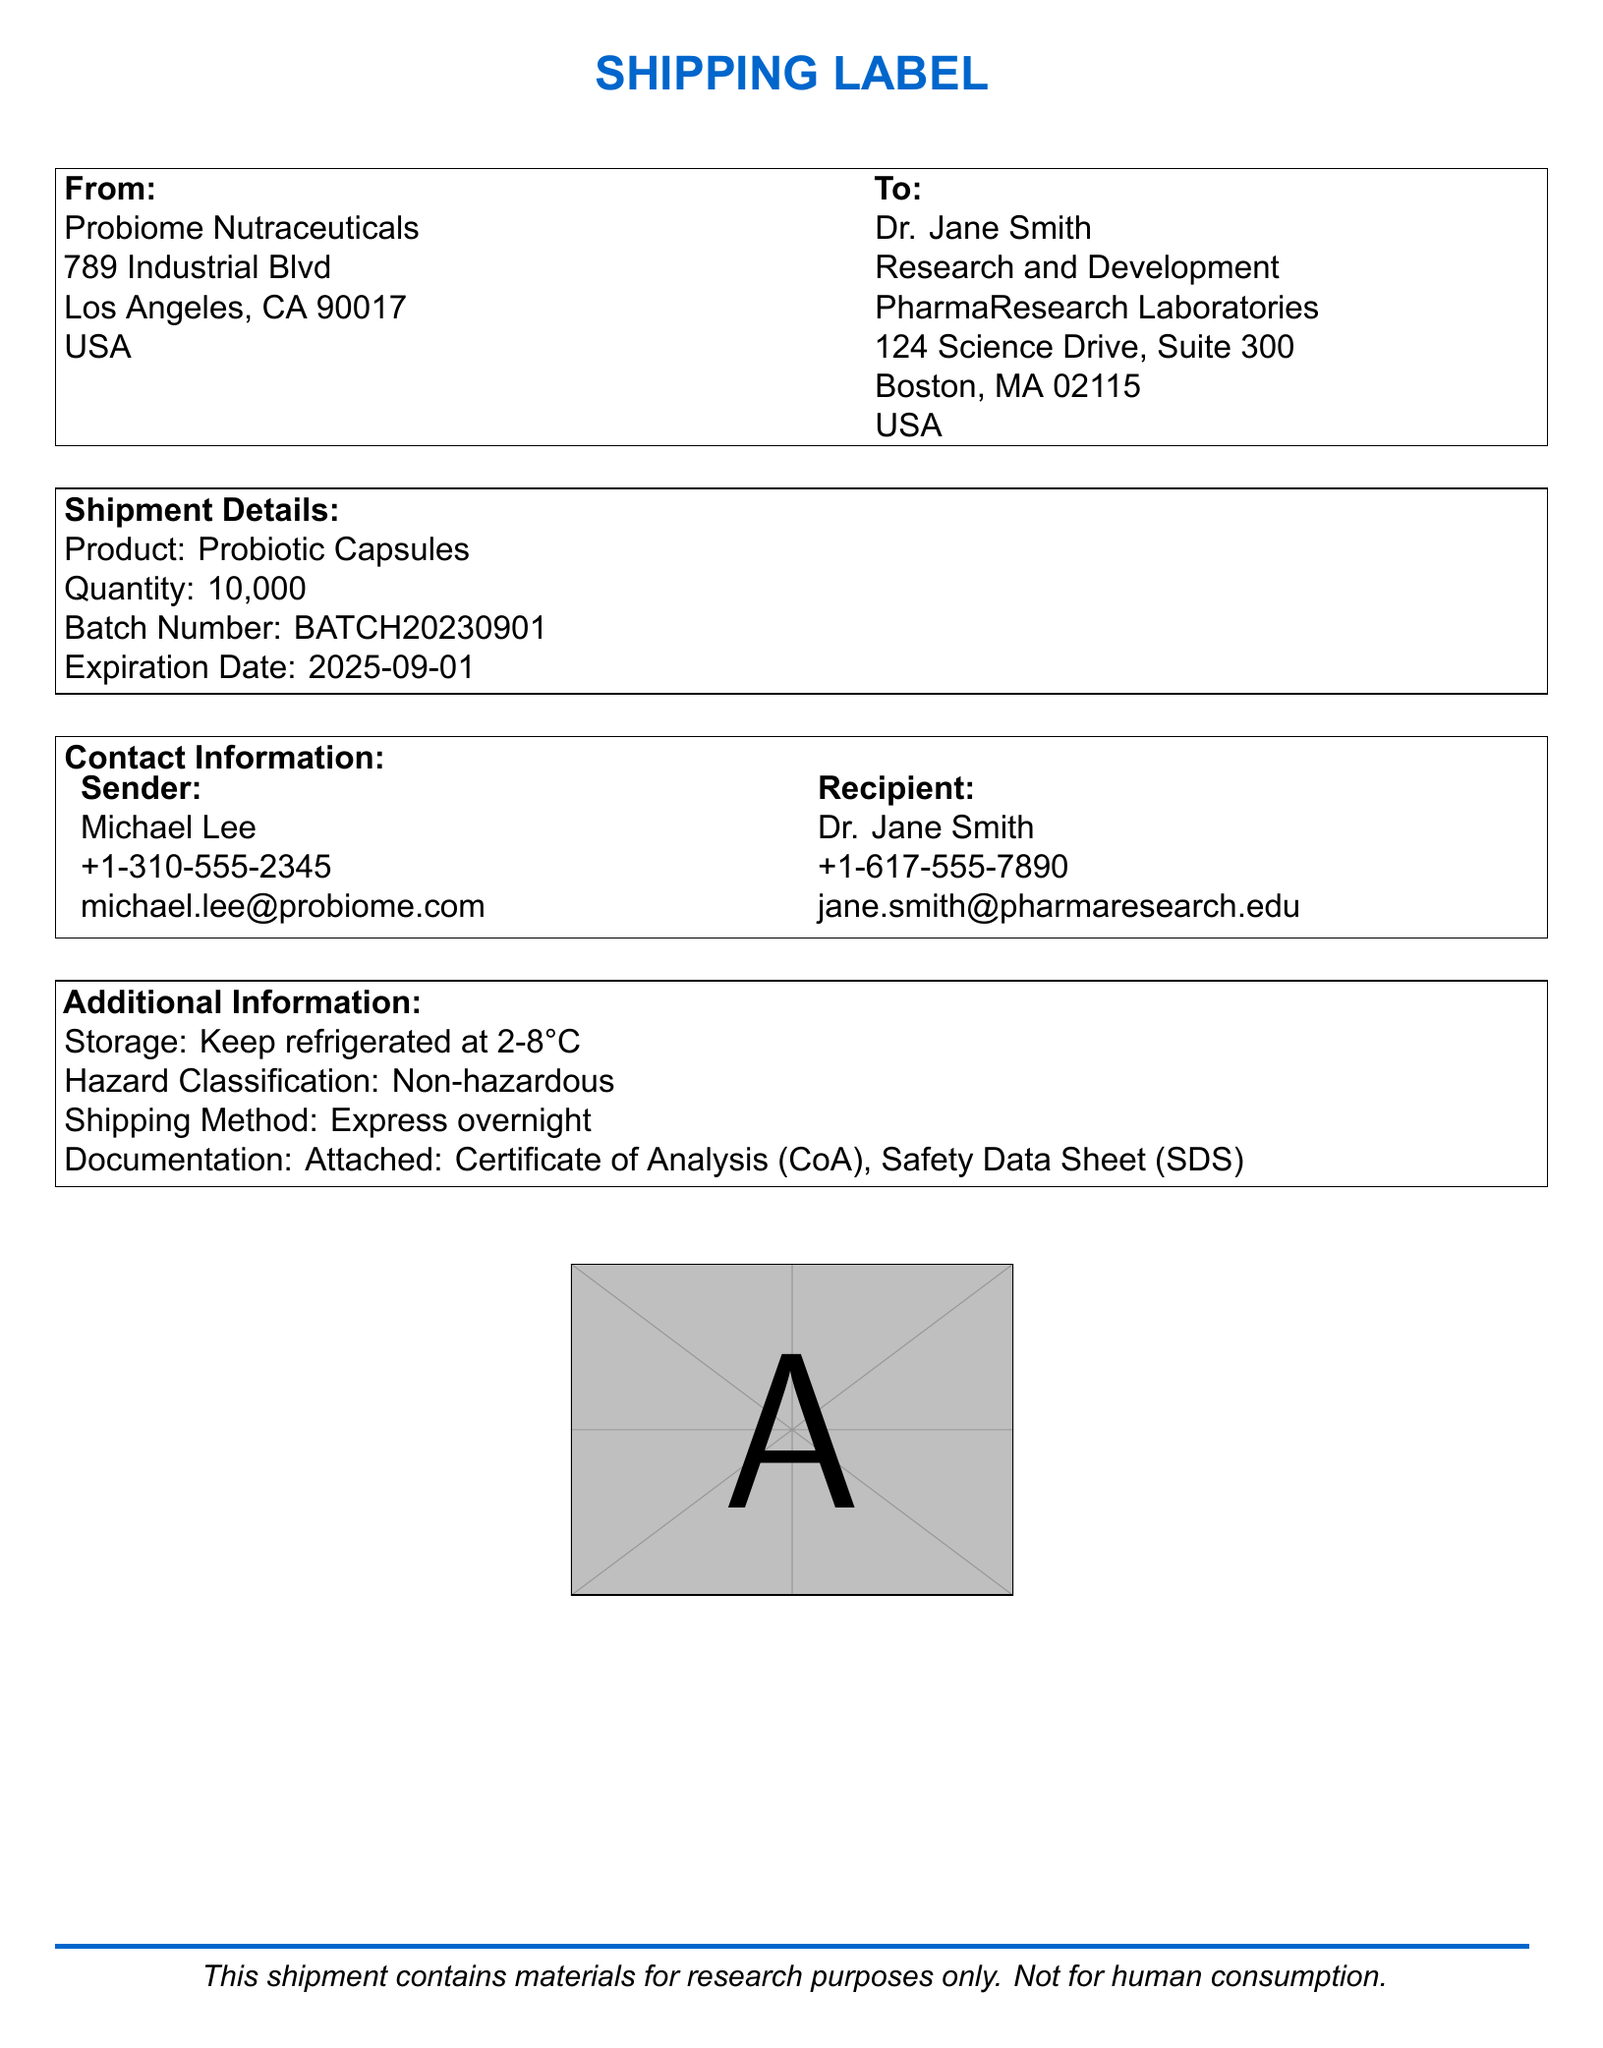What is the quantity of probiotic capsules? The quantity is specified in the shipment details section of the document.
Answer: 10,000 What is the batch number of the product? The batch number is listed under the shipment details.
Answer: BATCH20230901 What is the expiration date of the probiotic capsules? The expiration date is provided in the shipment details section.
Answer: 2025-09-01 Who is the sender of the shipment? The sender's details are included in the contact information section.
Answer: Michael Lee What is the shipping method used for this order? The shipping method is stated in the additional information section.
Answer: Express overnight Where should the probiotic capsules be stored? The storage instructions are specified in the additional information section.
Answer: Keep refrigerated at 2-8°C What is the hazard classification of the product? The hazard classification is mentioned in the additional information section.
Answer: Non-hazardous Who is the recipient of the shipment? The recipient's details are located in the 'To' section of the document.
Answer: Dr. Jane Smith What is the phone number of the recipient? The recipient's phone number is listed in the contact information table.
Answer: +1-617-555-7890 